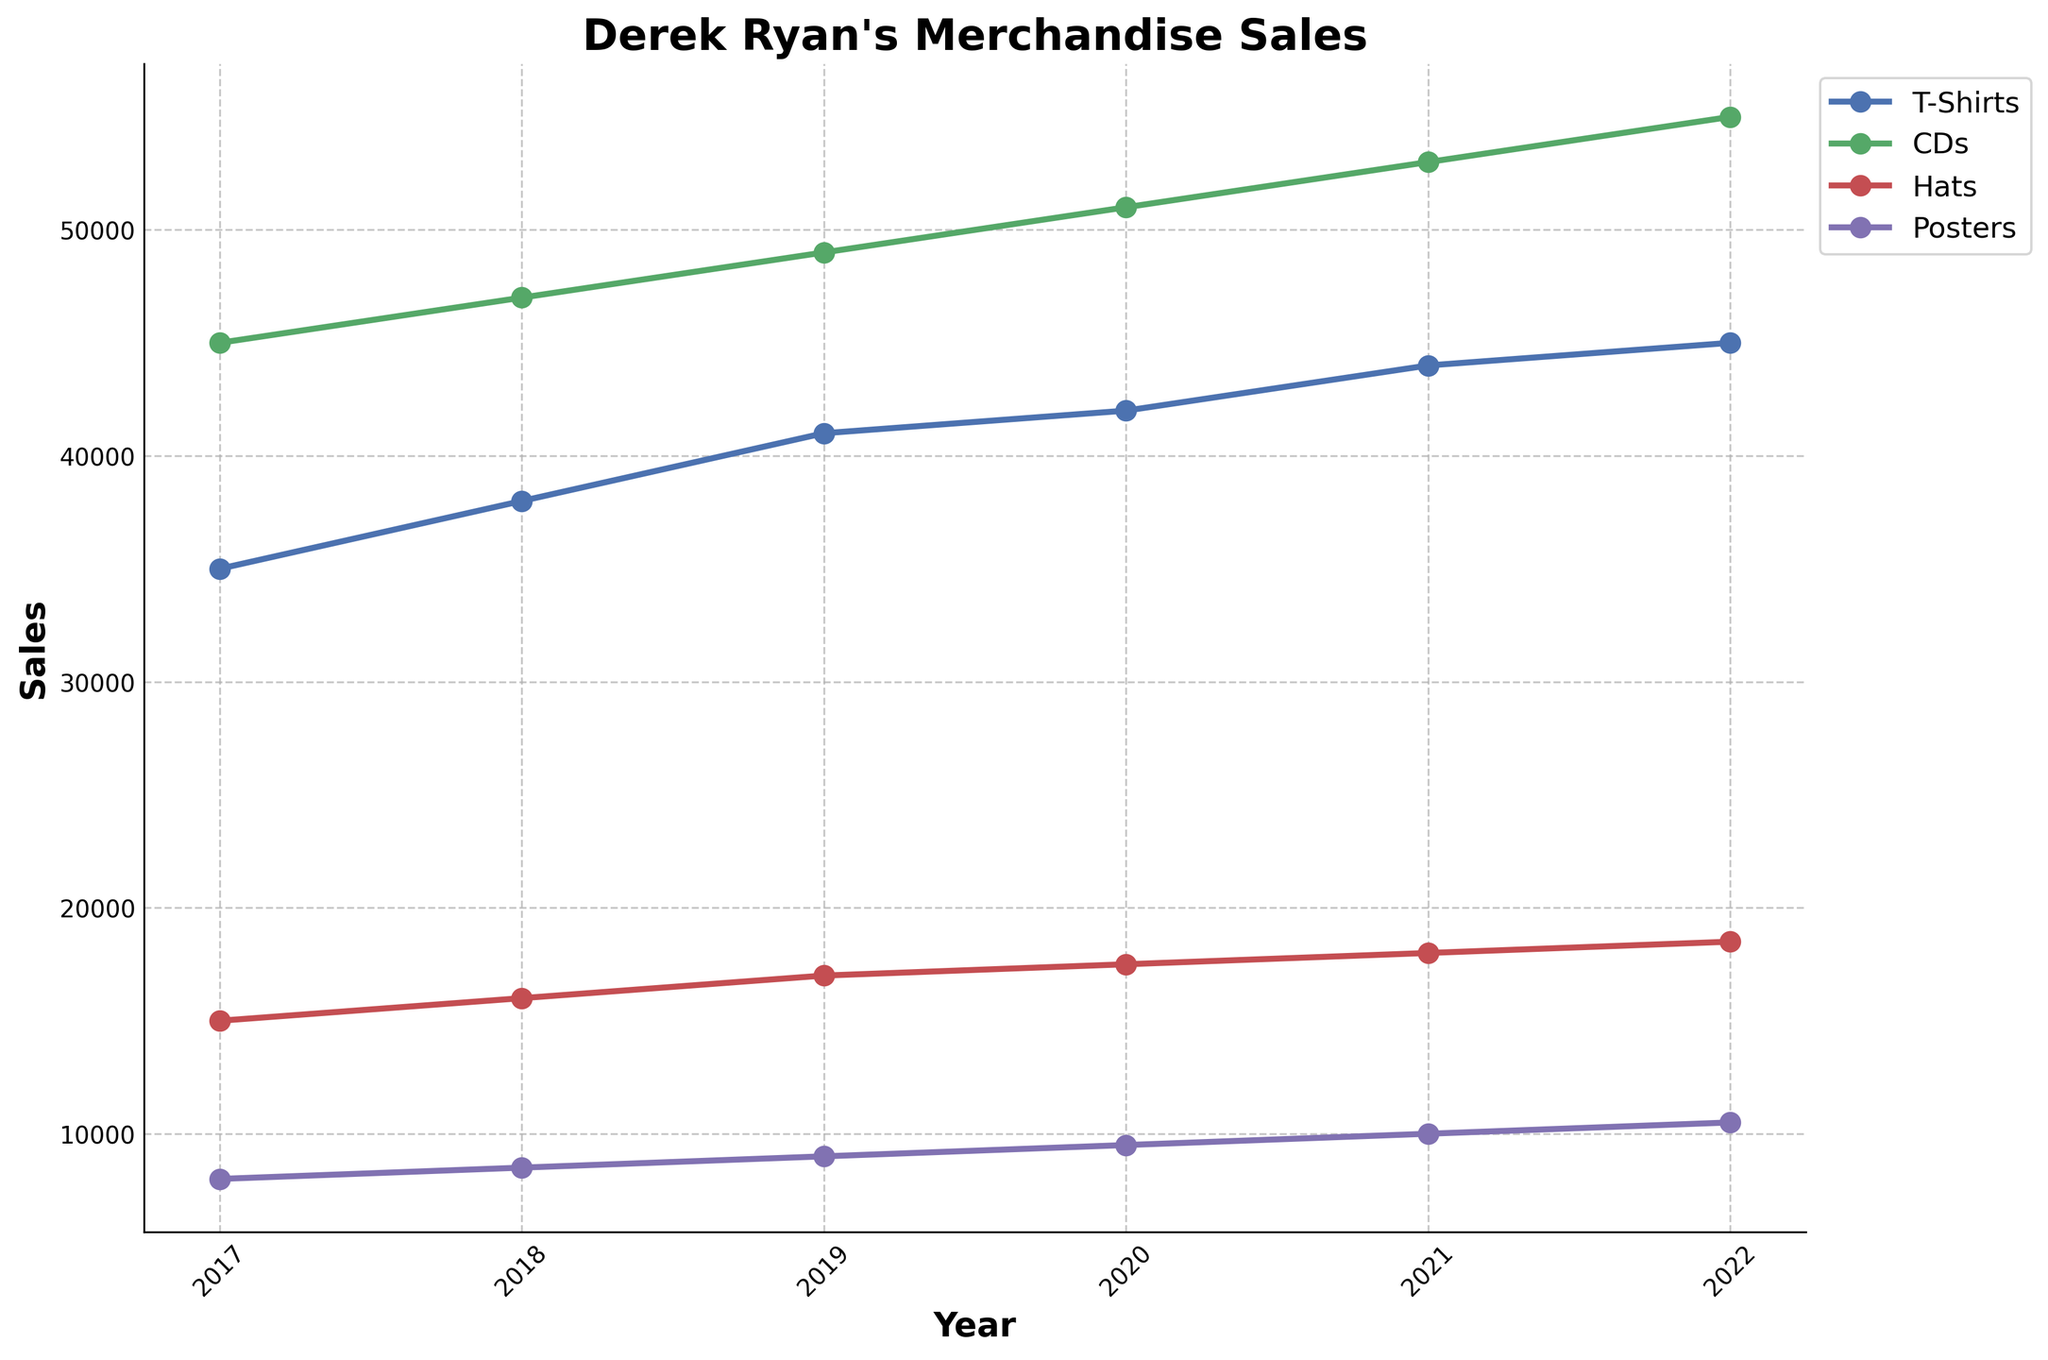what is the title of the plot? The title is located at the top center of the plot; it describes what the plot is about. In this case, the title is "Derek Ryan's Merchandise Sales."
Answer: Derek Ryan's Merchandise Sales What year had the highest sales for CDs? By observing the plot, locate the line representing CD sales and find the point with the highest value along its vertical axis. This occurs in the year 2022.
Answer: 2022 Which category had the lowest sales in 2017? Identify all the categories for the year 2017 from the plot. The category with the smallest value along the vertical axis is Posters.
Answer: Posters What is the total sales figure for T-Shirts in 2019 and 2020 combined? First, find the sales figures for T-Shirts in 2019 and 2020 from the plot. The values are 41000 and 42000 respectively. Add these two numbers together: 41000 + 42000 = 83000.
Answer: 83000 How do the trends for Posters sales change from 2017 to 2022? Observe the line representing Posters sales from 2017 to 2022. Notice the overall direction and pattern, which shows a consistent increase in sales each year.
Answer: Consistent increase Which year saw the greatest increase in Hats sales compared to the previous year? Observe the yearly changes in the Hats sales line and calculate the difference for each year. The greatest increase is between 2021 and 2022, where sales increased by 500 (18500 - 18000).
Answer: 2022 On average, how many T-Shirts were sold each year from 2017 to 2022? Calculate the total sales for T-Shirts from 2017 to 2022 by summing the annual figures: 35000 + 38000 + 41000 + 42000 + 44000 + 45000 = 245000. Divide by the number of years (6): 245000 / 6 = 40833.33.
Answer: 40833.33 What was the sales difference between CDs and Hats in 2021? Find the sales figures for CDs and Hats in 2021 from the plot. The values are 53000 and 18000, respectively. Subtract the sales of Hats from CDs: 53000 - 18000 = 35000.
Answer: 35000 What trend can you observe for overall merchandise sales from 2017 to 2022? Summarize the trends for all product categories. Each category shows an overall increase in sales including T-Shirts, CDs, Hats, and Posters. Therefore, overall merchandise sales have increased each year.
Answer: Increasing Which category has the most stable sales figures over the years? By examining the variability and changes in the lines for each category, Posters show the least fluctuation over the years, indicating the most stable sales.
Answer: Posters 